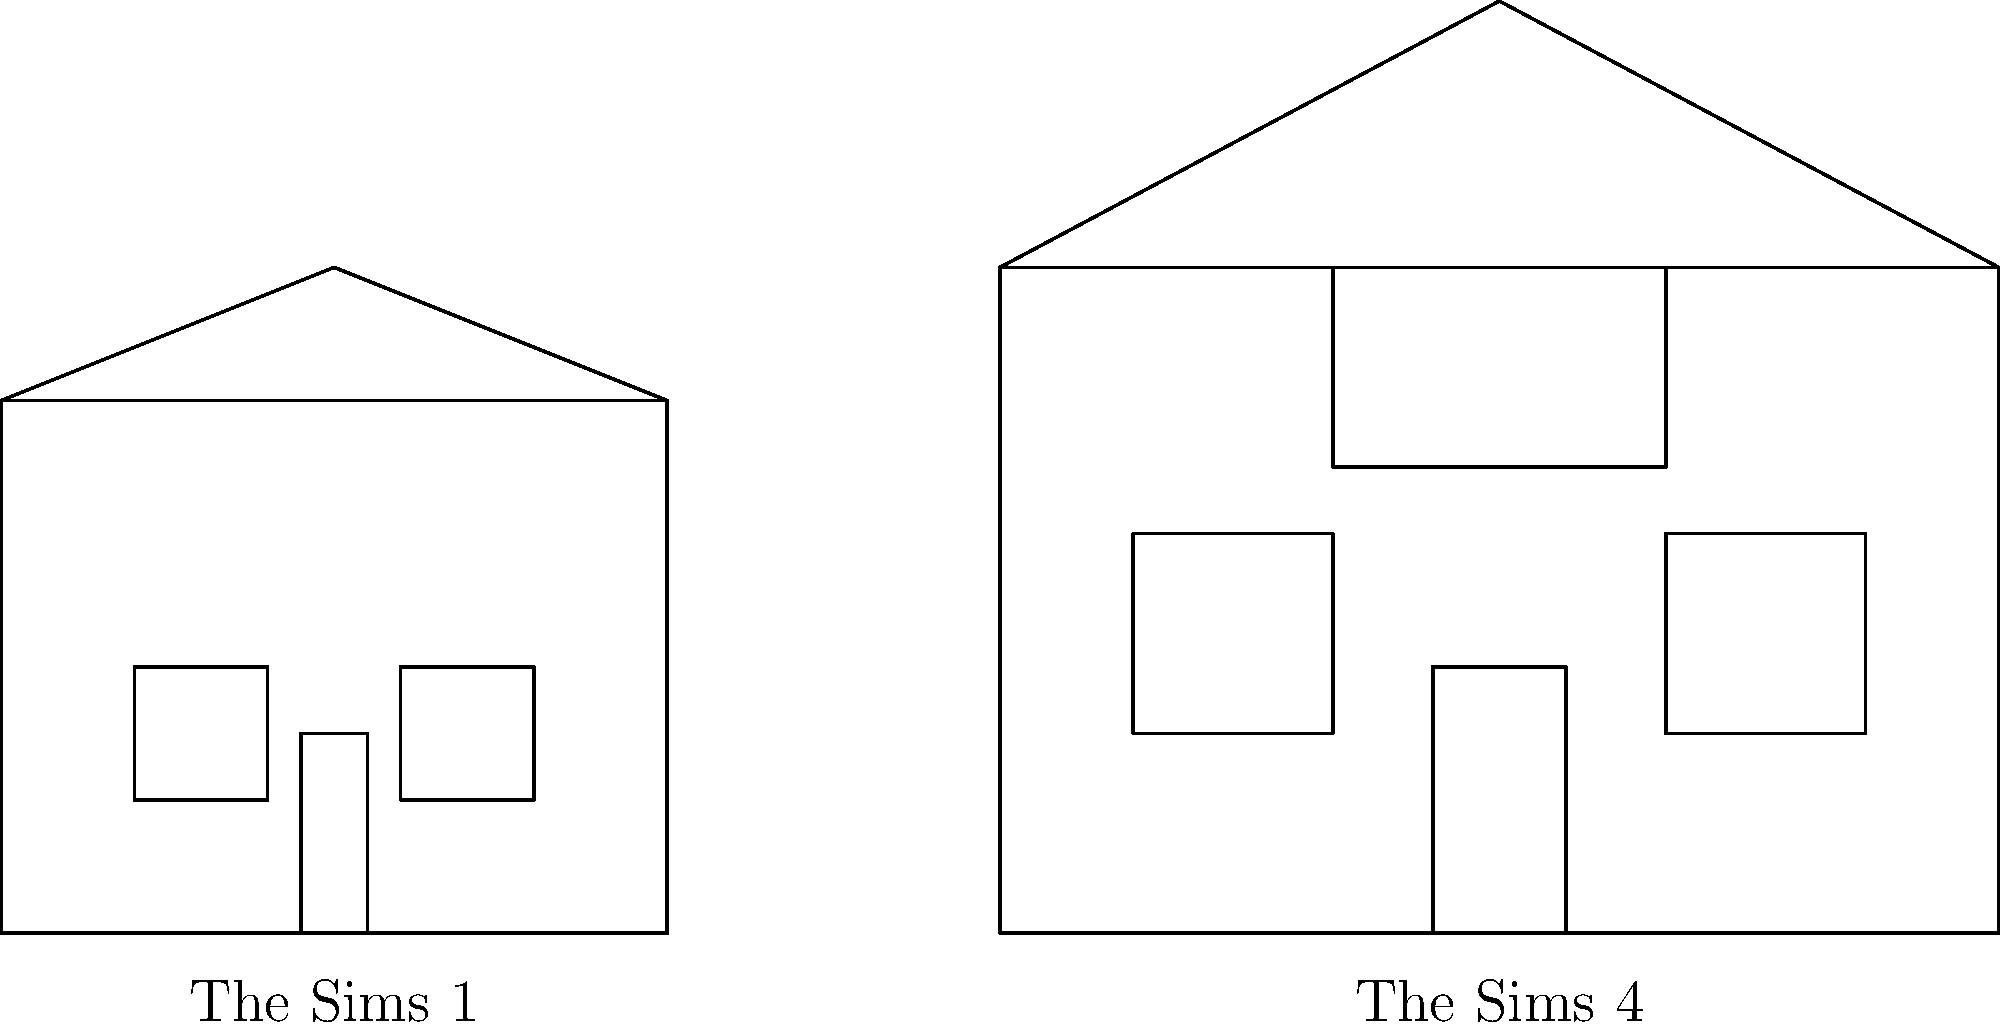Compare the architectural styles of the houses shown in the blueprints for The Sims 1 and The Sims 4. Which key feature, present in The Sims 4 house, represents a significant evolution in building capabilities compared to The Sims 1? To answer this question, let's analyze the blueprints step-by-step:

1. The Sims 1 house:
   - Simple rectangular shape
   - Basic triangular roof
   - Two small, square windows
   - Single-story design
   - Basic door placement

2. The Sims 4 house:
   - Larger, more complex rectangular shape
   - Steeper, more prominent roof
   - Larger, rectangular windows
   - Two-story design
   - More detailed door placement

3. Key differences:
   - The Sims 4 house is larger and more detailed overall
   - The roof in The Sims 4 is more prominent and stylized
   - Windows in The Sims 4 are larger and more diverse in shape

4. Significant evolution:
   The most notable feature present in The Sims 4 house that's absent in The Sims 1 is the balcony. This represents a significant evolution in building capabilities because:
   - It adds a new dimension to the house design
   - It allows for more complex, multi-level structures
   - It provides additional outdoor living space
   - It demonstrates the ability to create more realistic and diverse architectural styles

The balcony feature showcases the increased complexity and flexibility in house design that The Sims 4 offers compared to the original game, staying true to the series' evolution while maintaining its core building concepts.
Answer: Balcony 